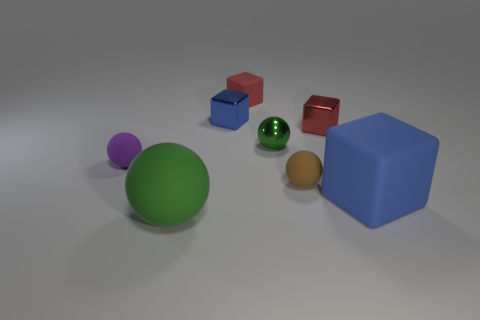Add 1 small purple rubber cylinders. How many objects exist? 9 Subtract 3 balls. How many balls are left? 1 Subtract all purple spheres. How many spheres are left? 3 Subtract all tiny purple spheres. How many spheres are left? 3 Subtract 0 purple cylinders. How many objects are left? 8 Subtract all cyan balls. Subtract all cyan cylinders. How many balls are left? 4 Subtract all green blocks. How many brown balls are left? 1 Subtract all small blue shiny cubes. Subtract all tiny red shiny blocks. How many objects are left? 6 Add 5 red matte blocks. How many red matte blocks are left? 6 Add 4 red metallic objects. How many red metallic objects exist? 5 